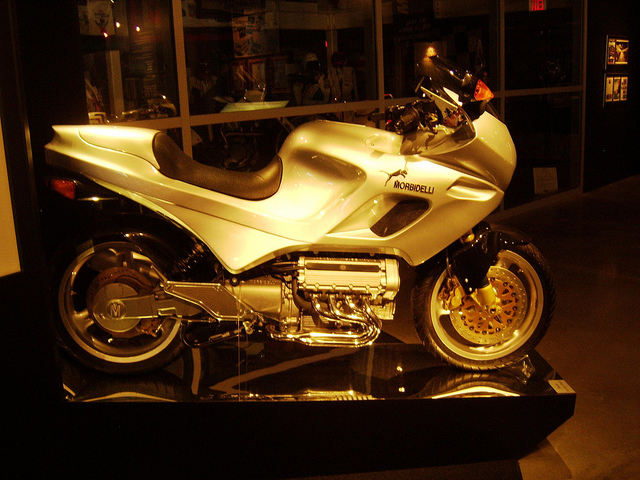Please identify all text content in this image. MORBIOELU 